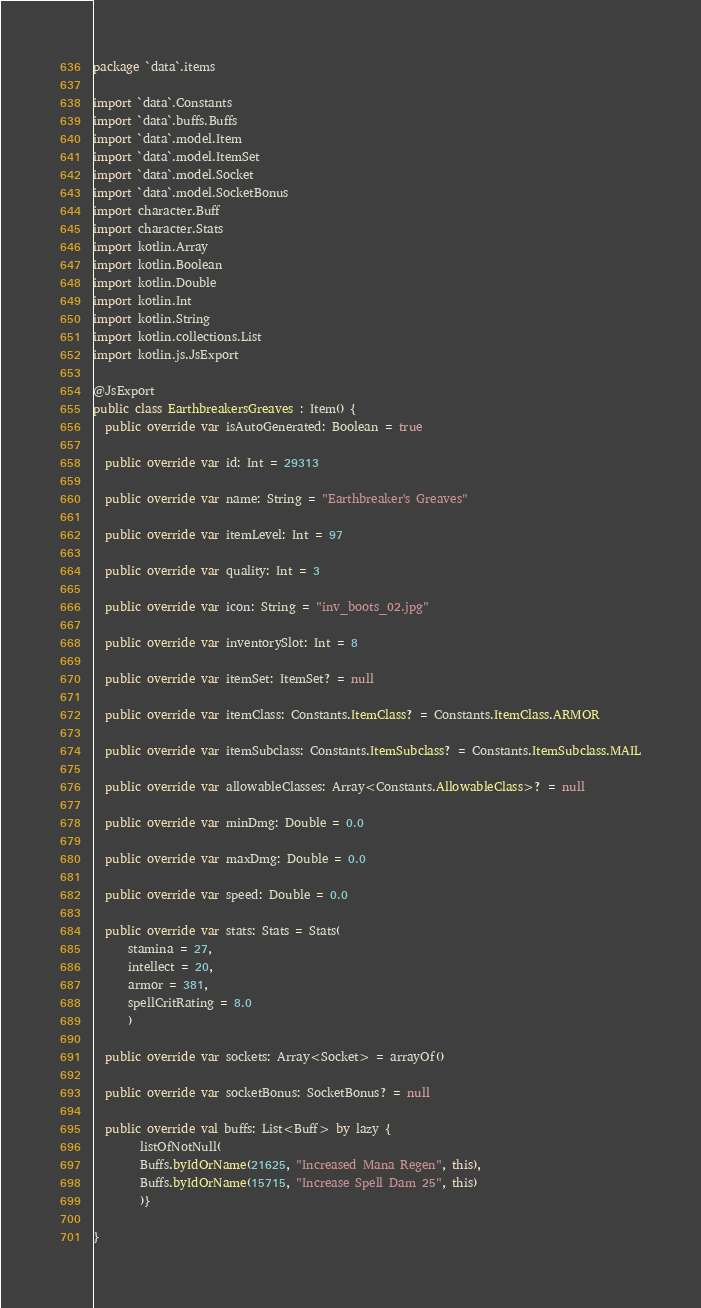<code> <loc_0><loc_0><loc_500><loc_500><_Kotlin_>package `data`.items

import `data`.Constants
import `data`.buffs.Buffs
import `data`.model.Item
import `data`.model.ItemSet
import `data`.model.Socket
import `data`.model.SocketBonus
import character.Buff
import character.Stats
import kotlin.Array
import kotlin.Boolean
import kotlin.Double
import kotlin.Int
import kotlin.String
import kotlin.collections.List
import kotlin.js.JsExport

@JsExport
public class EarthbreakersGreaves : Item() {
  public override var isAutoGenerated: Boolean = true

  public override var id: Int = 29313

  public override var name: String = "Earthbreaker's Greaves"

  public override var itemLevel: Int = 97

  public override var quality: Int = 3

  public override var icon: String = "inv_boots_02.jpg"

  public override var inventorySlot: Int = 8

  public override var itemSet: ItemSet? = null

  public override var itemClass: Constants.ItemClass? = Constants.ItemClass.ARMOR

  public override var itemSubclass: Constants.ItemSubclass? = Constants.ItemSubclass.MAIL

  public override var allowableClasses: Array<Constants.AllowableClass>? = null

  public override var minDmg: Double = 0.0

  public override var maxDmg: Double = 0.0

  public override var speed: Double = 0.0

  public override var stats: Stats = Stats(
      stamina = 27,
      intellect = 20,
      armor = 381,
      spellCritRating = 8.0
      )

  public override var sockets: Array<Socket> = arrayOf()

  public override var socketBonus: SocketBonus? = null

  public override val buffs: List<Buff> by lazy {
        listOfNotNull(
        Buffs.byIdOrName(21625, "Increased Mana Regen", this),
        Buffs.byIdOrName(15715, "Increase Spell Dam 25", this)
        )}

}
</code> 